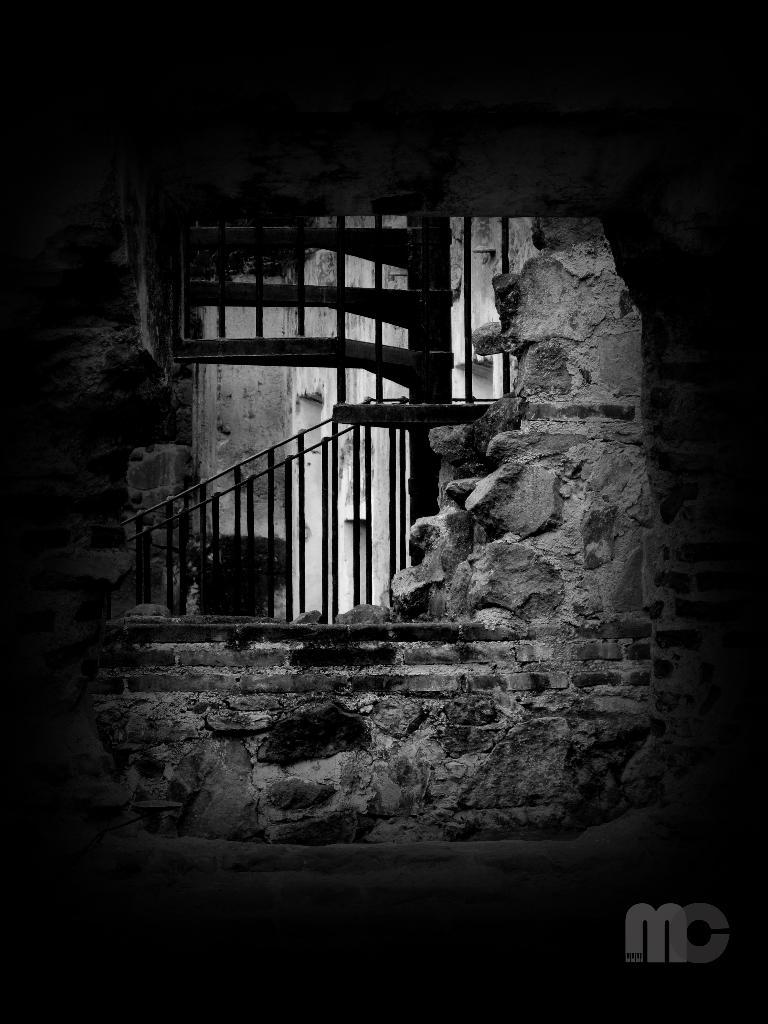What is the color scheme of the image? The image is black and white. What type of structure can be seen in the image? There is a wall in the image. What architectural feature is present in the image? There are stairs in the image. What type of notebook is visible on the stairs in the image? There is no notebook present in the image. How many bags can be seen on the wall in the image? There are no bags present in the image. 